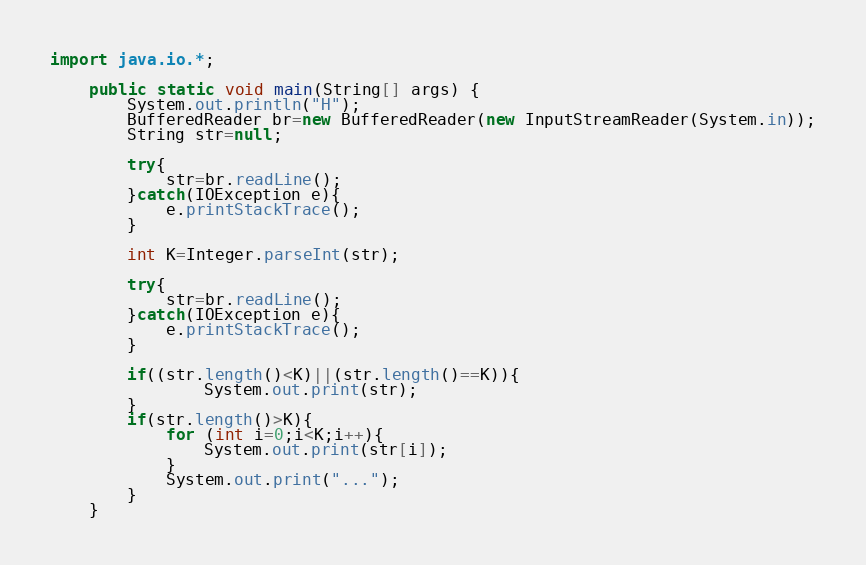Convert code to text. <code><loc_0><loc_0><loc_500><loc_500><_Java_>import java.io.*;

    public static void main(String[] args) {
        System.out.println("H");
        BufferedReader br=new BufferedReader(new InputStreamReader(System.in));
        String str=null;

        try{
            str=br.readLine();
        }catch(IOException e){
            e.printStackTrace();
        }

        int K=Integer.parseInt(str);

        try{
            str=br.readLine();
        }catch(IOException e){
            e.printStackTrace();
        }

        if((str.length()<K)||(str.length()==K)){
                System.out.print(str);
        }
        if(str.length()>K){
            for (int i=0;i<K;i++){
                System.out.print(str[i]);
            }
            System.out.print("...");
        }
    }</code> 